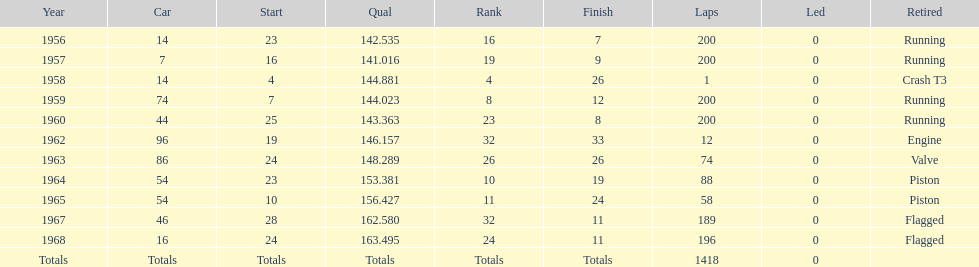What year did he have the same number car as 1964? 1965. 